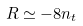Convert formula to latex. <formula><loc_0><loc_0><loc_500><loc_500>R \simeq - 8 n _ { t }</formula> 